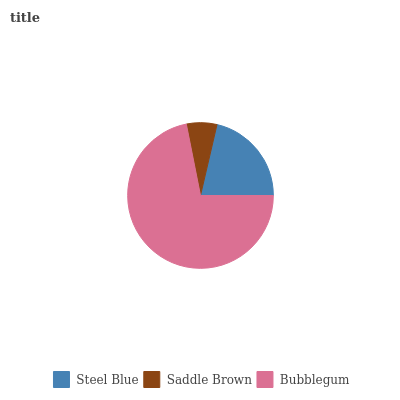Is Saddle Brown the minimum?
Answer yes or no. Yes. Is Bubblegum the maximum?
Answer yes or no. Yes. Is Bubblegum the minimum?
Answer yes or no. No. Is Saddle Brown the maximum?
Answer yes or no. No. Is Bubblegum greater than Saddle Brown?
Answer yes or no. Yes. Is Saddle Brown less than Bubblegum?
Answer yes or no. Yes. Is Saddle Brown greater than Bubblegum?
Answer yes or no. No. Is Bubblegum less than Saddle Brown?
Answer yes or no. No. Is Steel Blue the high median?
Answer yes or no. Yes. Is Steel Blue the low median?
Answer yes or no. Yes. Is Bubblegum the high median?
Answer yes or no. No. Is Bubblegum the low median?
Answer yes or no. No. 